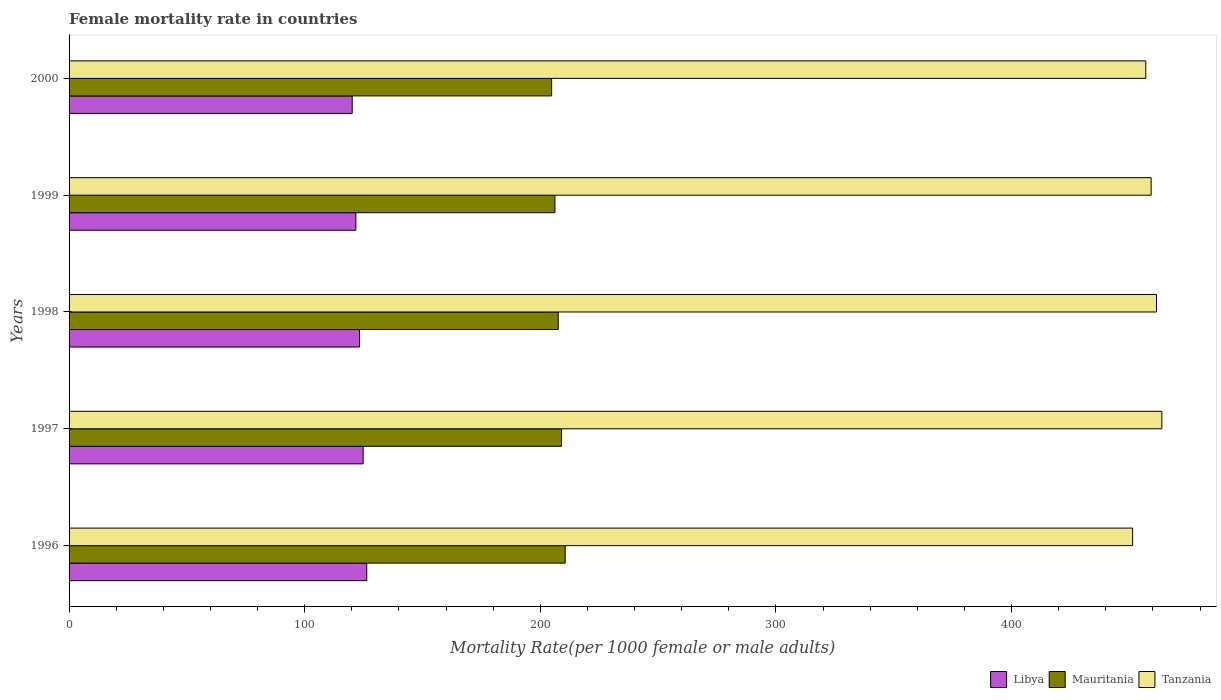Are the number of bars per tick equal to the number of legend labels?
Ensure brevity in your answer.  Yes. How many bars are there on the 1st tick from the top?
Ensure brevity in your answer.  3. How many bars are there on the 2nd tick from the bottom?
Make the answer very short. 3. What is the female mortality rate in Libya in 1998?
Your answer should be very brief. 123.25. Across all years, what is the maximum female mortality rate in Libya?
Your answer should be very brief. 126.34. Across all years, what is the minimum female mortality rate in Mauritania?
Your response must be concise. 204.8. In which year was the female mortality rate in Tanzania minimum?
Offer a very short reply. 1996. What is the total female mortality rate in Libya in the graph?
Provide a short and direct response. 616.26. What is the difference between the female mortality rate in Libya in 1997 and that in 2000?
Keep it short and to the point. 4.64. What is the difference between the female mortality rate in Mauritania in 2000 and the female mortality rate in Tanzania in 1998?
Make the answer very short. -256.7. What is the average female mortality rate in Libya per year?
Your answer should be very brief. 123.25. In the year 1997, what is the difference between the female mortality rate in Tanzania and female mortality rate in Libya?
Provide a succinct answer. 338.97. In how many years, is the female mortality rate in Libya greater than 180 ?
Your response must be concise. 0. What is the ratio of the female mortality rate in Tanzania in 1997 to that in 2000?
Make the answer very short. 1.01. Is the female mortality rate in Libya in 1996 less than that in 1999?
Your response must be concise. No. Is the difference between the female mortality rate in Tanzania in 1998 and 2000 greater than the difference between the female mortality rate in Libya in 1998 and 2000?
Your response must be concise. Yes. What is the difference between the highest and the second highest female mortality rate in Libya?
Provide a succinct answer. 1.53. What is the difference between the highest and the lowest female mortality rate in Tanzania?
Offer a terse response. 12.41. What does the 1st bar from the top in 2000 represents?
Provide a short and direct response. Tanzania. What does the 1st bar from the bottom in 1998 represents?
Make the answer very short. Libya. Is it the case that in every year, the sum of the female mortality rate in Libya and female mortality rate in Tanzania is greater than the female mortality rate in Mauritania?
Ensure brevity in your answer.  Yes. How many bars are there?
Offer a terse response. 15. How many years are there in the graph?
Provide a short and direct response. 5. What is the difference between two consecutive major ticks on the X-axis?
Give a very brief answer. 100. Are the values on the major ticks of X-axis written in scientific E-notation?
Provide a succinct answer. No. How many legend labels are there?
Your answer should be compact. 3. What is the title of the graph?
Your answer should be very brief. Female mortality rate in countries. Does "Slovenia" appear as one of the legend labels in the graph?
Give a very brief answer. No. What is the label or title of the X-axis?
Make the answer very short. Mortality Rate(per 1000 female or male adults). What is the label or title of the Y-axis?
Provide a succinct answer. Years. What is the Mortality Rate(per 1000 female or male adults) in Libya in 1996?
Your answer should be very brief. 126.34. What is the Mortality Rate(per 1000 female or male adults) in Mauritania in 1996?
Your answer should be very brief. 210.55. What is the Mortality Rate(per 1000 female or male adults) of Tanzania in 1996?
Your response must be concise. 451.37. What is the Mortality Rate(per 1000 female or male adults) of Libya in 1997?
Offer a very short reply. 124.8. What is the Mortality Rate(per 1000 female or male adults) in Mauritania in 1997?
Provide a short and direct response. 209. What is the Mortality Rate(per 1000 female or male adults) of Tanzania in 1997?
Make the answer very short. 463.78. What is the Mortality Rate(per 1000 female or male adults) of Libya in 1998?
Provide a succinct answer. 123.25. What is the Mortality Rate(per 1000 female or male adults) in Mauritania in 1998?
Keep it short and to the point. 207.6. What is the Mortality Rate(per 1000 female or male adults) in Tanzania in 1998?
Give a very brief answer. 461.5. What is the Mortality Rate(per 1000 female or male adults) of Libya in 1999?
Give a very brief answer. 121.71. What is the Mortality Rate(per 1000 female or male adults) of Mauritania in 1999?
Provide a succinct answer. 206.2. What is the Mortality Rate(per 1000 female or male adults) of Tanzania in 1999?
Provide a short and direct response. 459.23. What is the Mortality Rate(per 1000 female or male adults) in Libya in 2000?
Provide a short and direct response. 120.16. What is the Mortality Rate(per 1000 female or male adults) in Mauritania in 2000?
Ensure brevity in your answer.  204.8. What is the Mortality Rate(per 1000 female or male adults) of Tanzania in 2000?
Keep it short and to the point. 456.95. Across all years, what is the maximum Mortality Rate(per 1000 female or male adults) in Libya?
Ensure brevity in your answer.  126.34. Across all years, what is the maximum Mortality Rate(per 1000 female or male adults) in Mauritania?
Your response must be concise. 210.55. Across all years, what is the maximum Mortality Rate(per 1000 female or male adults) of Tanzania?
Your answer should be compact. 463.78. Across all years, what is the minimum Mortality Rate(per 1000 female or male adults) of Libya?
Give a very brief answer. 120.16. Across all years, what is the minimum Mortality Rate(per 1000 female or male adults) in Mauritania?
Offer a very short reply. 204.8. Across all years, what is the minimum Mortality Rate(per 1000 female or male adults) in Tanzania?
Offer a terse response. 451.37. What is the total Mortality Rate(per 1000 female or male adults) of Libya in the graph?
Keep it short and to the point. 616.26. What is the total Mortality Rate(per 1000 female or male adults) of Mauritania in the graph?
Your answer should be very brief. 1038.15. What is the total Mortality Rate(per 1000 female or male adults) of Tanzania in the graph?
Offer a very short reply. 2292.83. What is the difference between the Mortality Rate(per 1000 female or male adults) in Libya in 1996 and that in 1997?
Keep it short and to the point. 1.53. What is the difference between the Mortality Rate(per 1000 female or male adults) in Mauritania in 1996 and that in 1997?
Your answer should be compact. 1.55. What is the difference between the Mortality Rate(per 1000 female or male adults) of Tanzania in 1996 and that in 1997?
Your answer should be compact. -12.41. What is the difference between the Mortality Rate(per 1000 female or male adults) in Libya in 1996 and that in 1998?
Keep it short and to the point. 3.08. What is the difference between the Mortality Rate(per 1000 female or male adults) of Mauritania in 1996 and that in 1998?
Give a very brief answer. 2.95. What is the difference between the Mortality Rate(per 1000 female or male adults) of Tanzania in 1996 and that in 1998?
Make the answer very short. -10.13. What is the difference between the Mortality Rate(per 1000 female or male adults) of Libya in 1996 and that in 1999?
Provide a short and direct response. 4.63. What is the difference between the Mortality Rate(per 1000 female or male adults) of Mauritania in 1996 and that in 1999?
Provide a succinct answer. 4.35. What is the difference between the Mortality Rate(per 1000 female or male adults) in Tanzania in 1996 and that in 1999?
Ensure brevity in your answer.  -7.86. What is the difference between the Mortality Rate(per 1000 female or male adults) in Libya in 1996 and that in 2000?
Keep it short and to the point. 6.17. What is the difference between the Mortality Rate(per 1000 female or male adults) in Mauritania in 1996 and that in 2000?
Make the answer very short. 5.75. What is the difference between the Mortality Rate(per 1000 female or male adults) in Tanzania in 1996 and that in 2000?
Offer a very short reply. -5.58. What is the difference between the Mortality Rate(per 1000 female or male adults) in Libya in 1997 and that in 1998?
Offer a terse response. 1.55. What is the difference between the Mortality Rate(per 1000 female or male adults) in Mauritania in 1997 and that in 1998?
Give a very brief answer. 1.4. What is the difference between the Mortality Rate(per 1000 female or male adults) in Tanzania in 1997 and that in 1998?
Your answer should be compact. 2.27. What is the difference between the Mortality Rate(per 1000 female or male adults) of Libya in 1997 and that in 1999?
Your answer should be very brief. 3.1. What is the difference between the Mortality Rate(per 1000 female or male adults) of Tanzania in 1997 and that in 1999?
Your response must be concise. 4.55. What is the difference between the Mortality Rate(per 1000 female or male adults) of Libya in 1997 and that in 2000?
Offer a very short reply. 4.64. What is the difference between the Mortality Rate(per 1000 female or male adults) of Mauritania in 1997 and that in 2000?
Provide a short and direct response. 4.2. What is the difference between the Mortality Rate(per 1000 female or male adults) in Tanzania in 1997 and that in 2000?
Make the answer very short. 6.82. What is the difference between the Mortality Rate(per 1000 female or male adults) of Libya in 1998 and that in 1999?
Offer a very short reply. 1.55. What is the difference between the Mortality Rate(per 1000 female or male adults) of Tanzania in 1998 and that in 1999?
Make the answer very short. 2.27. What is the difference between the Mortality Rate(per 1000 female or male adults) of Libya in 1998 and that in 2000?
Provide a short and direct response. 3.09. What is the difference between the Mortality Rate(per 1000 female or male adults) of Mauritania in 1998 and that in 2000?
Offer a very short reply. 2.8. What is the difference between the Mortality Rate(per 1000 female or male adults) of Tanzania in 1998 and that in 2000?
Provide a short and direct response. 4.55. What is the difference between the Mortality Rate(per 1000 female or male adults) of Libya in 1999 and that in 2000?
Provide a succinct answer. 1.55. What is the difference between the Mortality Rate(per 1000 female or male adults) of Tanzania in 1999 and that in 2000?
Your response must be concise. 2.27. What is the difference between the Mortality Rate(per 1000 female or male adults) of Libya in 1996 and the Mortality Rate(per 1000 female or male adults) of Mauritania in 1997?
Your response must be concise. -82.66. What is the difference between the Mortality Rate(per 1000 female or male adults) in Libya in 1996 and the Mortality Rate(per 1000 female or male adults) in Tanzania in 1997?
Your response must be concise. -337.44. What is the difference between the Mortality Rate(per 1000 female or male adults) in Mauritania in 1996 and the Mortality Rate(per 1000 female or male adults) in Tanzania in 1997?
Ensure brevity in your answer.  -253.22. What is the difference between the Mortality Rate(per 1000 female or male adults) of Libya in 1996 and the Mortality Rate(per 1000 female or male adults) of Mauritania in 1998?
Make the answer very short. -81.26. What is the difference between the Mortality Rate(per 1000 female or male adults) of Libya in 1996 and the Mortality Rate(per 1000 female or male adults) of Tanzania in 1998?
Give a very brief answer. -335.17. What is the difference between the Mortality Rate(per 1000 female or male adults) of Mauritania in 1996 and the Mortality Rate(per 1000 female or male adults) of Tanzania in 1998?
Your answer should be very brief. -250.95. What is the difference between the Mortality Rate(per 1000 female or male adults) in Libya in 1996 and the Mortality Rate(per 1000 female or male adults) in Mauritania in 1999?
Make the answer very short. -79.86. What is the difference between the Mortality Rate(per 1000 female or male adults) in Libya in 1996 and the Mortality Rate(per 1000 female or male adults) in Tanzania in 1999?
Offer a very short reply. -332.89. What is the difference between the Mortality Rate(per 1000 female or male adults) in Mauritania in 1996 and the Mortality Rate(per 1000 female or male adults) in Tanzania in 1999?
Ensure brevity in your answer.  -248.68. What is the difference between the Mortality Rate(per 1000 female or male adults) of Libya in 1996 and the Mortality Rate(per 1000 female or male adults) of Mauritania in 2000?
Your answer should be compact. -78.46. What is the difference between the Mortality Rate(per 1000 female or male adults) of Libya in 1996 and the Mortality Rate(per 1000 female or male adults) of Tanzania in 2000?
Give a very brief answer. -330.62. What is the difference between the Mortality Rate(per 1000 female or male adults) of Mauritania in 1996 and the Mortality Rate(per 1000 female or male adults) of Tanzania in 2000?
Your answer should be very brief. -246.4. What is the difference between the Mortality Rate(per 1000 female or male adults) in Libya in 1997 and the Mortality Rate(per 1000 female or male adults) in Mauritania in 1998?
Keep it short and to the point. -82.8. What is the difference between the Mortality Rate(per 1000 female or male adults) of Libya in 1997 and the Mortality Rate(per 1000 female or male adults) of Tanzania in 1998?
Your answer should be compact. -336.7. What is the difference between the Mortality Rate(per 1000 female or male adults) in Mauritania in 1997 and the Mortality Rate(per 1000 female or male adults) in Tanzania in 1998?
Your response must be concise. -252.5. What is the difference between the Mortality Rate(per 1000 female or male adults) in Libya in 1997 and the Mortality Rate(per 1000 female or male adults) in Mauritania in 1999?
Your answer should be compact. -81.4. What is the difference between the Mortality Rate(per 1000 female or male adults) of Libya in 1997 and the Mortality Rate(per 1000 female or male adults) of Tanzania in 1999?
Provide a short and direct response. -334.43. What is the difference between the Mortality Rate(per 1000 female or male adults) in Mauritania in 1997 and the Mortality Rate(per 1000 female or male adults) in Tanzania in 1999?
Your answer should be compact. -250.23. What is the difference between the Mortality Rate(per 1000 female or male adults) in Libya in 1997 and the Mortality Rate(per 1000 female or male adults) in Mauritania in 2000?
Your answer should be compact. -80. What is the difference between the Mortality Rate(per 1000 female or male adults) in Libya in 1997 and the Mortality Rate(per 1000 female or male adults) in Tanzania in 2000?
Your answer should be compact. -332.15. What is the difference between the Mortality Rate(per 1000 female or male adults) of Mauritania in 1997 and the Mortality Rate(per 1000 female or male adults) of Tanzania in 2000?
Your response must be concise. -247.95. What is the difference between the Mortality Rate(per 1000 female or male adults) in Libya in 1998 and the Mortality Rate(per 1000 female or male adults) in Mauritania in 1999?
Offer a very short reply. -82.94. What is the difference between the Mortality Rate(per 1000 female or male adults) of Libya in 1998 and the Mortality Rate(per 1000 female or male adults) of Tanzania in 1999?
Your response must be concise. -335.97. What is the difference between the Mortality Rate(per 1000 female or male adults) in Mauritania in 1998 and the Mortality Rate(per 1000 female or male adults) in Tanzania in 1999?
Offer a very short reply. -251.63. What is the difference between the Mortality Rate(per 1000 female or male adults) of Libya in 1998 and the Mortality Rate(per 1000 female or male adults) of Mauritania in 2000?
Your response must be concise. -81.55. What is the difference between the Mortality Rate(per 1000 female or male adults) in Libya in 1998 and the Mortality Rate(per 1000 female or male adults) in Tanzania in 2000?
Keep it short and to the point. -333.7. What is the difference between the Mortality Rate(per 1000 female or male adults) of Mauritania in 1998 and the Mortality Rate(per 1000 female or male adults) of Tanzania in 2000?
Offer a terse response. -249.35. What is the difference between the Mortality Rate(per 1000 female or male adults) in Libya in 1999 and the Mortality Rate(per 1000 female or male adults) in Mauritania in 2000?
Your answer should be very brief. -83.09. What is the difference between the Mortality Rate(per 1000 female or male adults) of Libya in 1999 and the Mortality Rate(per 1000 female or male adults) of Tanzania in 2000?
Keep it short and to the point. -335.25. What is the difference between the Mortality Rate(per 1000 female or male adults) of Mauritania in 1999 and the Mortality Rate(per 1000 female or male adults) of Tanzania in 2000?
Your answer should be very brief. -250.75. What is the average Mortality Rate(per 1000 female or male adults) in Libya per year?
Your answer should be compact. 123.25. What is the average Mortality Rate(per 1000 female or male adults) of Mauritania per year?
Give a very brief answer. 207.63. What is the average Mortality Rate(per 1000 female or male adults) of Tanzania per year?
Make the answer very short. 458.57. In the year 1996, what is the difference between the Mortality Rate(per 1000 female or male adults) of Libya and Mortality Rate(per 1000 female or male adults) of Mauritania?
Provide a short and direct response. -84.22. In the year 1996, what is the difference between the Mortality Rate(per 1000 female or male adults) in Libya and Mortality Rate(per 1000 female or male adults) in Tanzania?
Offer a terse response. -325.03. In the year 1996, what is the difference between the Mortality Rate(per 1000 female or male adults) of Mauritania and Mortality Rate(per 1000 female or male adults) of Tanzania?
Provide a succinct answer. -240.82. In the year 1997, what is the difference between the Mortality Rate(per 1000 female or male adults) in Libya and Mortality Rate(per 1000 female or male adults) in Mauritania?
Provide a succinct answer. -84.2. In the year 1997, what is the difference between the Mortality Rate(per 1000 female or male adults) of Libya and Mortality Rate(per 1000 female or male adults) of Tanzania?
Your response must be concise. -338.97. In the year 1997, what is the difference between the Mortality Rate(per 1000 female or male adults) in Mauritania and Mortality Rate(per 1000 female or male adults) in Tanzania?
Provide a short and direct response. -254.78. In the year 1998, what is the difference between the Mortality Rate(per 1000 female or male adults) of Libya and Mortality Rate(per 1000 female or male adults) of Mauritania?
Ensure brevity in your answer.  -84.34. In the year 1998, what is the difference between the Mortality Rate(per 1000 female or male adults) in Libya and Mortality Rate(per 1000 female or male adults) in Tanzania?
Give a very brief answer. -338.25. In the year 1998, what is the difference between the Mortality Rate(per 1000 female or male adults) of Mauritania and Mortality Rate(per 1000 female or male adults) of Tanzania?
Give a very brief answer. -253.9. In the year 1999, what is the difference between the Mortality Rate(per 1000 female or male adults) in Libya and Mortality Rate(per 1000 female or male adults) in Mauritania?
Your answer should be compact. -84.49. In the year 1999, what is the difference between the Mortality Rate(per 1000 female or male adults) of Libya and Mortality Rate(per 1000 female or male adults) of Tanzania?
Ensure brevity in your answer.  -337.52. In the year 1999, what is the difference between the Mortality Rate(per 1000 female or male adults) in Mauritania and Mortality Rate(per 1000 female or male adults) in Tanzania?
Provide a short and direct response. -253.03. In the year 2000, what is the difference between the Mortality Rate(per 1000 female or male adults) in Libya and Mortality Rate(per 1000 female or male adults) in Mauritania?
Offer a terse response. -84.64. In the year 2000, what is the difference between the Mortality Rate(per 1000 female or male adults) in Libya and Mortality Rate(per 1000 female or male adults) in Tanzania?
Your answer should be very brief. -336.79. In the year 2000, what is the difference between the Mortality Rate(per 1000 female or male adults) of Mauritania and Mortality Rate(per 1000 female or male adults) of Tanzania?
Your response must be concise. -252.15. What is the ratio of the Mortality Rate(per 1000 female or male adults) of Libya in 1996 to that in 1997?
Ensure brevity in your answer.  1.01. What is the ratio of the Mortality Rate(per 1000 female or male adults) of Mauritania in 1996 to that in 1997?
Offer a very short reply. 1.01. What is the ratio of the Mortality Rate(per 1000 female or male adults) of Tanzania in 1996 to that in 1997?
Your response must be concise. 0.97. What is the ratio of the Mortality Rate(per 1000 female or male adults) of Libya in 1996 to that in 1998?
Provide a succinct answer. 1.02. What is the ratio of the Mortality Rate(per 1000 female or male adults) in Mauritania in 1996 to that in 1998?
Keep it short and to the point. 1.01. What is the ratio of the Mortality Rate(per 1000 female or male adults) in Tanzania in 1996 to that in 1998?
Ensure brevity in your answer.  0.98. What is the ratio of the Mortality Rate(per 1000 female or male adults) of Libya in 1996 to that in 1999?
Provide a succinct answer. 1.04. What is the ratio of the Mortality Rate(per 1000 female or male adults) in Mauritania in 1996 to that in 1999?
Keep it short and to the point. 1.02. What is the ratio of the Mortality Rate(per 1000 female or male adults) of Tanzania in 1996 to that in 1999?
Your answer should be very brief. 0.98. What is the ratio of the Mortality Rate(per 1000 female or male adults) of Libya in 1996 to that in 2000?
Your answer should be compact. 1.05. What is the ratio of the Mortality Rate(per 1000 female or male adults) of Mauritania in 1996 to that in 2000?
Provide a succinct answer. 1.03. What is the ratio of the Mortality Rate(per 1000 female or male adults) of Tanzania in 1996 to that in 2000?
Provide a short and direct response. 0.99. What is the ratio of the Mortality Rate(per 1000 female or male adults) of Libya in 1997 to that in 1998?
Give a very brief answer. 1.01. What is the ratio of the Mortality Rate(per 1000 female or male adults) of Mauritania in 1997 to that in 1998?
Offer a terse response. 1.01. What is the ratio of the Mortality Rate(per 1000 female or male adults) of Tanzania in 1997 to that in 1998?
Provide a short and direct response. 1. What is the ratio of the Mortality Rate(per 1000 female or male adults) of Libya in 1997 to that in 1999?
Offer a very short reply. 1.03. What is the ratio of the Mortality Rate(per 1000 female or male adults) in Mauritania in 1997 to that in 1999?
Your response must be concise. 1.01. What is the ratio of the Mortality Rate(per 1000 female or male adults) of Tanzania in 1997 to that in 1999?
Provide a succinct answer. 1.01. What is the ratio of the Mortality Rate(per 1000 female or male adults) in Libya in 1997 to that in 2000?
Provide a succinct answer. 1.04. What is the ratio of the Mortality Rate(per 1000 female or male adults) in Mauritania in 1997 to that in 2000?
Your answer should be compact. 1.02. What is the ratio of the Mortality Rate(per 1000 female or male adults) in Tanzania in 1997 to that in 2000?
Give a very brief answer. 1.01. What is the ratio of the Mortality Rate(per 1000 female or male adults) of Libya in 1998 to that in 1999?
Offer a very short reply. 1.01. What is the ratio of the Mortality Rate(per 1000 female or male adults) of Mauritania in 1998 to that in 1999?
Provide a short and direct response. 1.01. What is the ratio of the Mortality Rate(per 1000 female or male adults) in Libya in 1998 to that in 2000?
Provide a succinct answer. 1.03. What is the ratio of the Mortality Rate(per 1000 female or male adults) of Mauritania in 1998 to that in 2000?
Ensure brevity in your answer.  1.01. What is the ratio of the Mortality Rate(per 1000 female or male adults) of Tanzania in 1998 to that in 2000?
Keep it short and to the point. 1.01. What is the ratio of the Mortality Rate(per 1000 female or male adults) in Libya in 1999 to that in 2000?
Provide a succinct answer. 1.01. What is the ratio of the Mortality Rate(per 1000 female or male adults) in Mauritania in 1999 to that in 2000?
Provide a short and direct response. 1.01. What is the difference between the highest and the second highest Mortality Rate(per 1000 female or male adults) in Libya?
Your answer should be very brief. 1.53. What is the difference between the highest and the second highest Mortality Rate(per 1000 female or male adults) in Mauritania?
Give a very brief answer. 1.55. What is the difference between the highest and the second highest Mortality Rate(per 1000 female or male adults) of Tanzania?
Your answer should be very brief. 2.27. What is the difference between the highest and the lowest Mortality Rate(per 1000 female or male adults) of Libya?
Keep it short and to the point. 6.17. What is the difference between the highest and the lowest Mortality Rate(per 1000 female or male adults) in Mauritania?
Offer a very short reply. 5.75. What is the difference between the highest and the lowest Mortality Rate(per 1000 female or male adults) of Tanzania?
Provide a succinct answer. 12.41. 